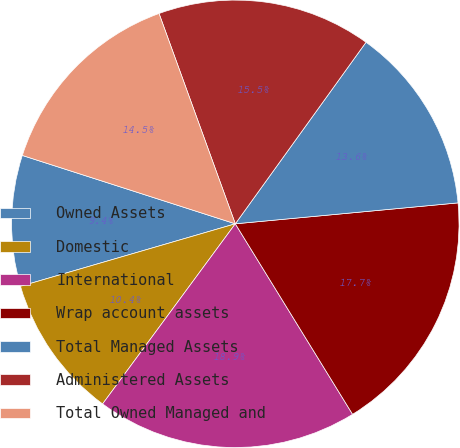Convert chart. <chart><loc_0><loc_0><loc_500><loc_500><pie_chart><fcel>Owned Assets<fcel>Domestic<fcel>International<fcel>Wrap account assets<fcel>Total Managed Assets<fcel>Administered Assets<fcel>Total Owned Managed and<nl><fcel>9.45%<fcel>10.39%<fcel>18.89%<fcel>17.71%<fcel>13.58%<fcel>15.47%<fcel>14.52%<nl></chart> 